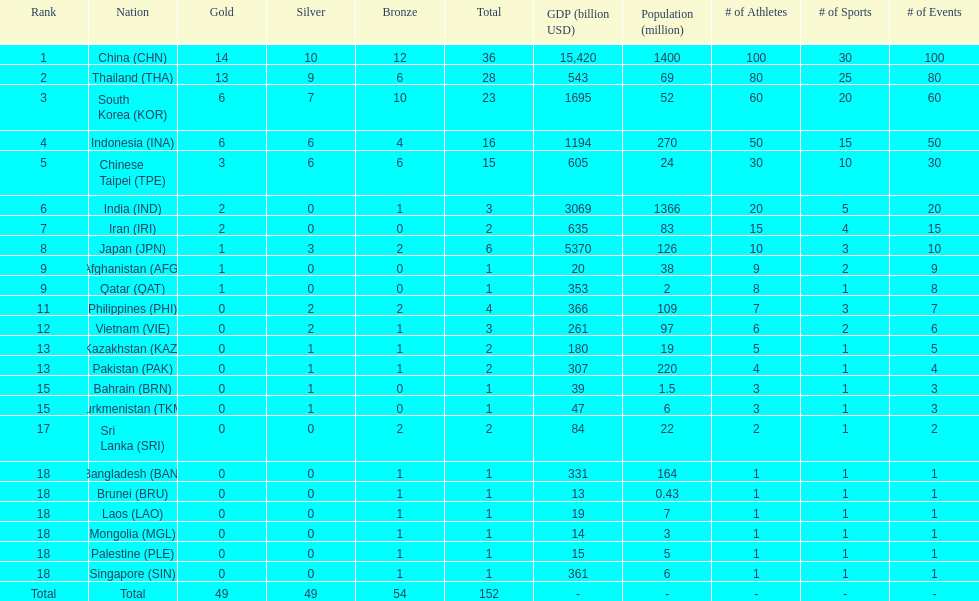How many total gold medal have been given? 49. Would you mind parsing the complete table? {'header': ['Rank', 'Nation', 'Gold', 'Silver', 'Bronze', 'Total', 'GDP (billion USD)', 'Population (million)', '# of Athletes', '# of Sports', '# of Events'], 'rows': [['1', 'China\xa0(CHN)', '14', '10', '12', '36', '15,420', '1400', '100', '30', '100'], ['2', 'Thailand\xa0(THA)', '13', '9', '6', '28', '543', '69', '80', '25', '80'], ['3', 'South Korea\xa0(KOR)', '6', '7', '10', '23', '1695', '52', '60', '20', '60'], ['4', 'Indonesia\xa0(INA)', '6', '6', '4', '16', '1194', '270', '50', '15', '50'], ['5', 'Chinese Taipei\xa0(TPE)', '3', '6', '6', '15', '605', '24', '30', '10', '30'], ['6', 'India\xa0(IND)', '2', '0', '1', '3', '3069', '1366', '20', '5', '20'], ['7', 'Iran\xa0(IRI)', '2', '0', '0', '2', '635', '83', '15', '4', '15'], ['8', 'Japan\xa0(JPN)', '1', '3', '2', '6', '5370', '126', '10', '3', '10'], ['9', 'Afghanistan\xa0(AFG)', '1', '0', '0', '1', '20', '38', '9', '2', '9'], ['9', 'Qatar\xa0(QAT)', '1', '0', '0', '1', '353', '2', '8', '1', '8'], ['11', 'Philippines\xa0(PHI)', '0', '2', '2', '4', '366', '109', '7', '3', '7'], ['12', 'Vietnam\xa0(VIE)', '0', '2', '1', '3', '261', '97', '6', '2', '6'], ['13', 'Kazakhstan\xa0(KAZ)', '0', '1', '1', '2', '180', '19', '5', '1', '5'], ['13', 'Pakistan\xa0(PAK)', '0', '1', '1', '2', '307', '220', '4', '1', '4'], ['15', 'Bahrain\xa0(BRN)', '0', '1', '0', '1', '39', '1.5', '3', '1', '3'], ['15', 'Turkmenistan\xa0(TKM)', '0', '1', '0', '1', '47', '6', '3', '1', '3'], ['17', 'Sri Lanka\xa0(SRI)', '0', '0', '2', '2', '84', '22', '2', '1', '2'], ['18', 'Bangladesh\xa0(BAN)', '0', '0', '1', '1', '331', '164', '1', '1', '1'], ['18', 'Brunei\xa0(BRU)', '0', '0', '1', '1', '13', '0.43', '1', '1', '1'], ['18', 'Laos\xa0(LAO)', '0', '0', '1', '1', '19', '7', '1', '1', '1'], ['18', 'Mongolia\xa0(MGL)', '0', '0', '1', '1', '14', '3', '1', '1', '1'], ['18', 'Palestine\xa0(PLE)', '0', '0', '1', '1', '15', '5', '1', '1', '1'], ['18', 'Singapore\xa0(SIN)', '0', '0', '1', '1', '361', '6', '1', '1', '1'], ['Total', 'Total', '49', '49', '54', '152', '-', '-', '-', '-', '-']]} 